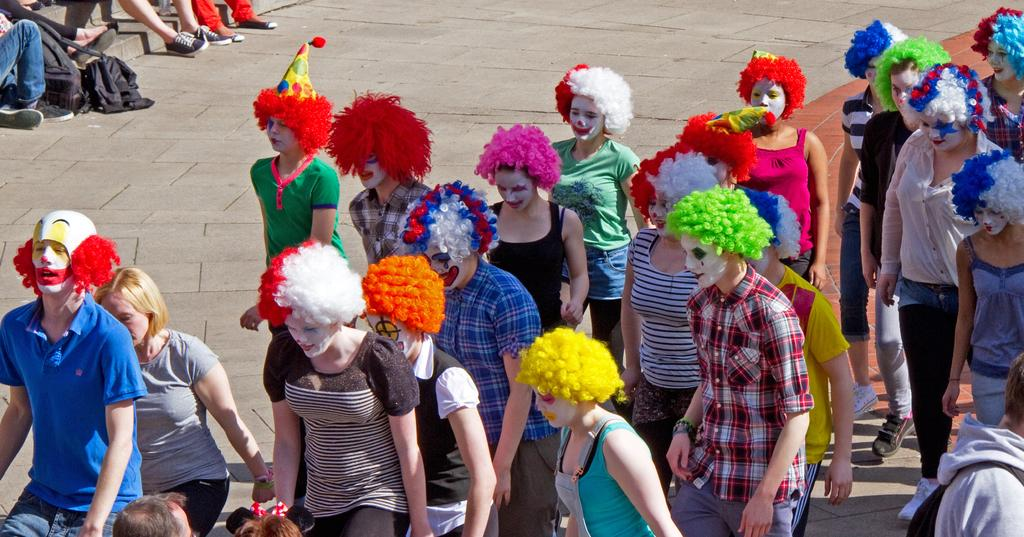What are the people in the image doing? The people in the image are walking on the road. What are the people wearing on their heads? The people are wearing caps. Where are some of the people sitting in the image? There are people sitting on stairs in the image. What type of yarn is being used by the farmer in the image? There is no farmer or yarn present in the image. How many boats can be seen in the image? There are no boats visible in the image. 